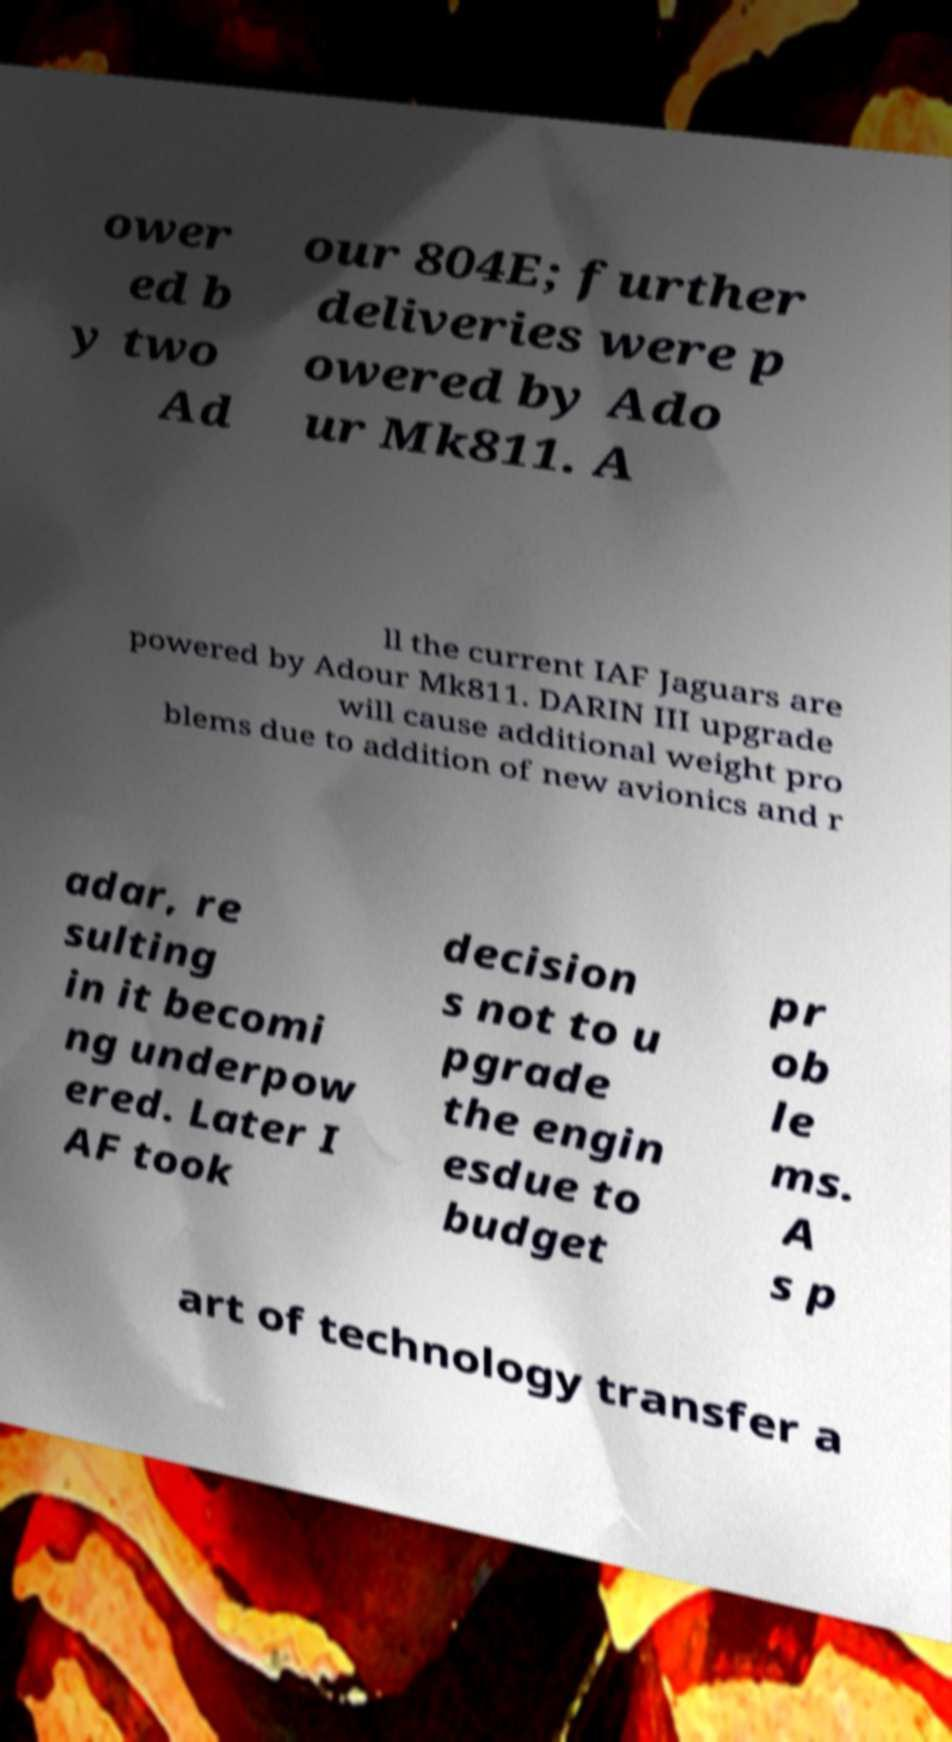For documentation purposes, I need the text within this image transcribed. Could you provide that? ower ed b y two Ad our 804E; further deliveries were p owered by Ado ur Mk811. A ll the current IAF Jaguars are powered by Adour Mk811. DARIN III upgrade will cause additional weight pro blems due to addition of new avionics and r adar, re sulting in it becomi ng underpow ered. Later I AF took decision s not to u pgrade the engin esdue to budget pr ob le ms. A s p art of technology transfer a 